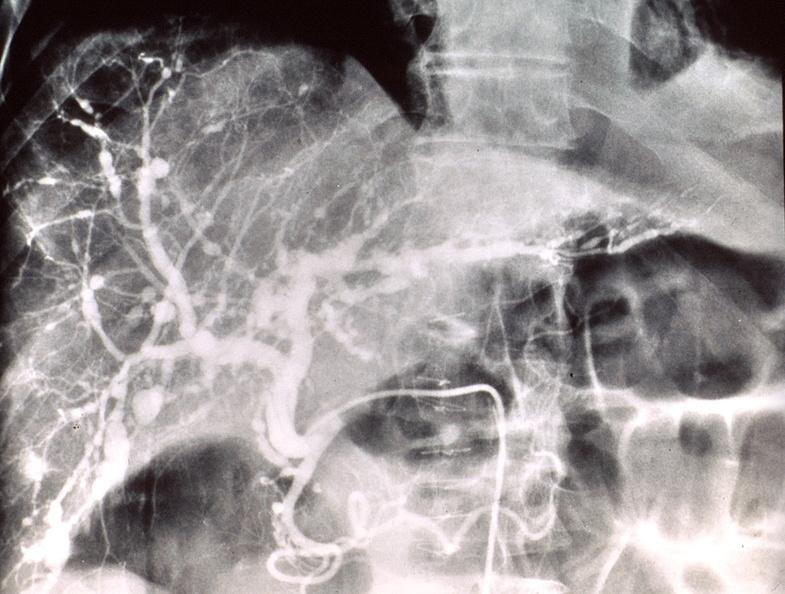does this image show poly arteritis nodosa, liver?
Answer the question using a single word or phrase. Yes 